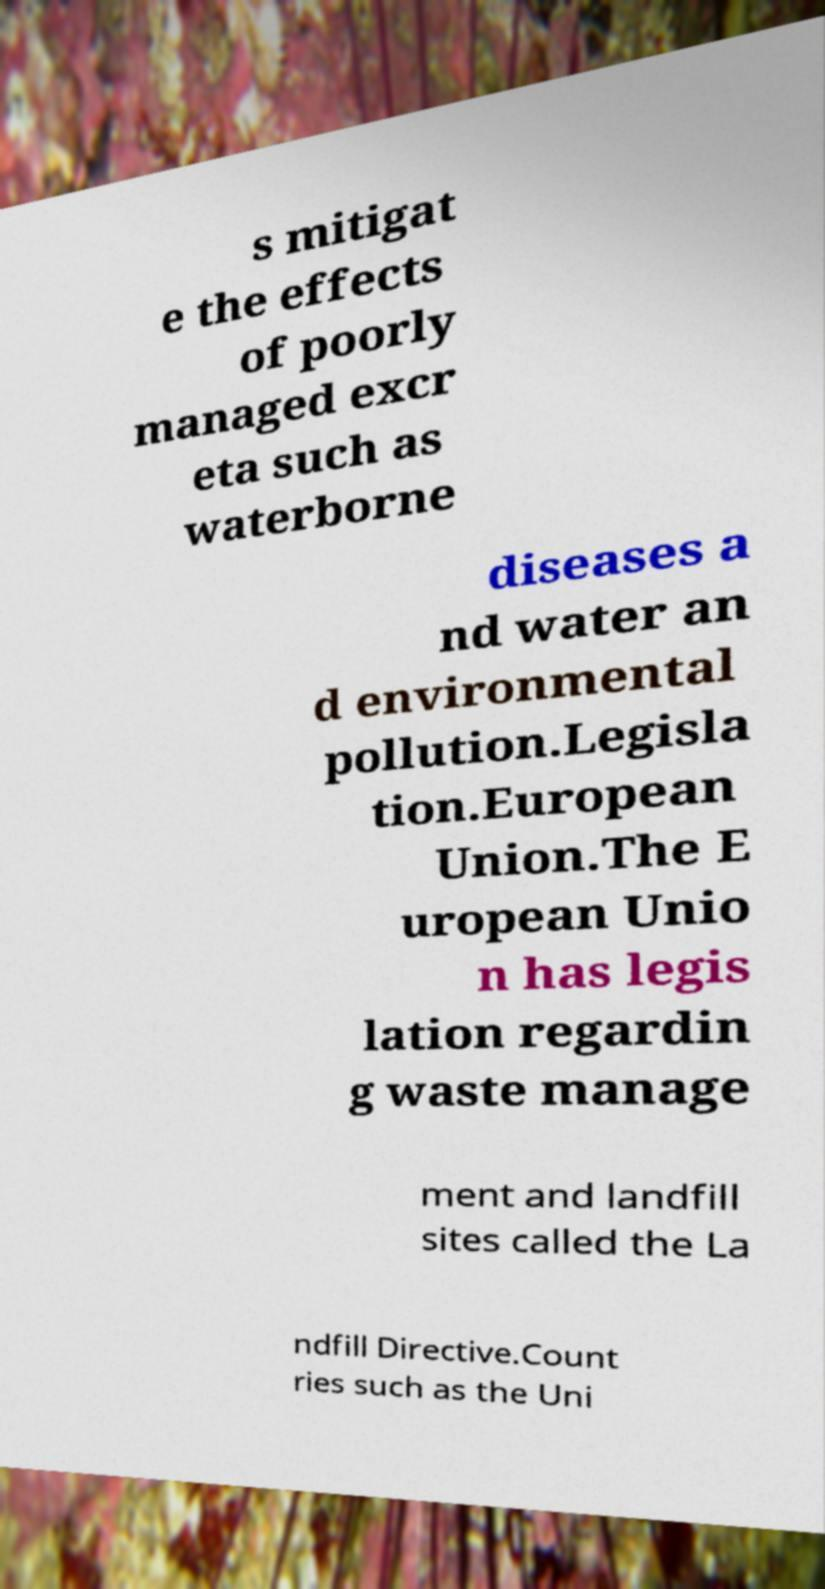Can you accurately transcribe the text from the provided image for me? s mitigat e the effects of poorly managed excr eta such as waterborne diseases a nd water an d environmental pollution.Legisla tion.European Union.The E uropean Unio n has legis lation regardin g waste manage ment and landfill sites called the La ndfill Directive.Count ries such as the Uni 